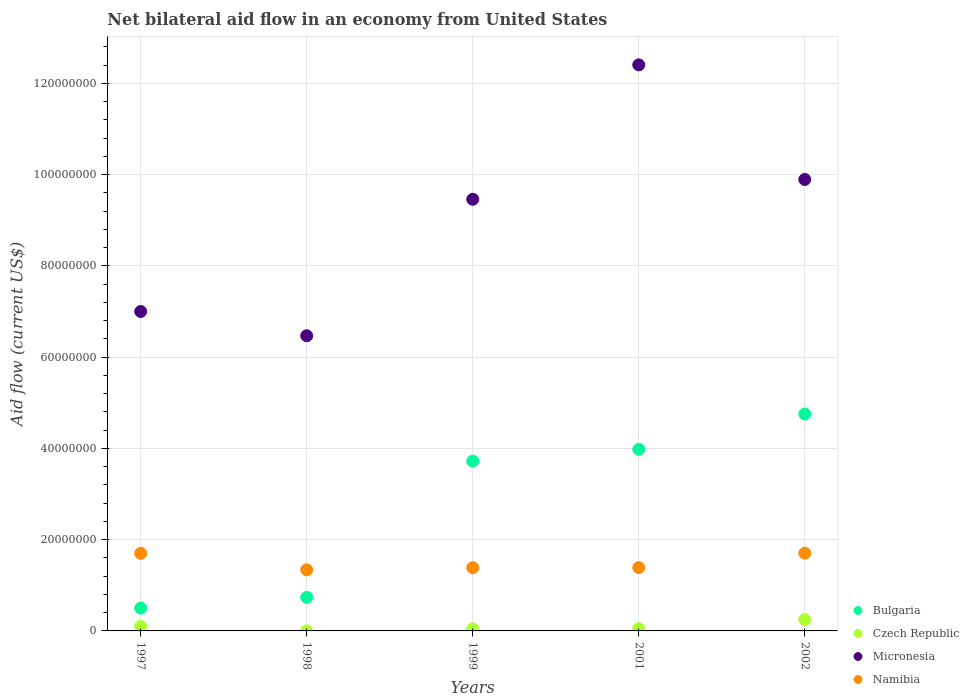Is the number of dotlines equal to the number of legend labels?
Your answer should be compact. Yes. What is the net bilateral aid flow in Namibia in 2002?
Offer a terse response. 1.70e+07. Across all years, what is the maximum net bilateral aid flow in Czech Republic?
Your response must be concise. 2.49e+06. Across all years, what is the minimum net bilateral aid flow in Bulgaria?
Offer a very short reply. 5.00e+06. In which year was the net bilateral aid flow in Micronesia maximum?
Ensure brevity in your answer.  2001. In which year was the net bilateral aid flow in Bulgaria minimum?
Provide a short and direct response. 1997. What is the total net bilateral aid flow in Czech Republic in the graph?
Provide a succinct answer. 4.45e+06. What is the difference between the net bilateral aid flow in Micronesia in 1998 and that in 2002?
Ensure brevity in your answer.  -3.42e+07. What is the difference between the net bilateral aid flow in Micronesia in 1997 and the net bilateral aid flow in Namibia in 2001?
Your answer should be compact. 5.61e+07. What is the average net bilateral aid flow in Namibia per year?
Keep it short and to the point. 1.50e+07. In the year 1997, what is the difference between the net bilateral aid flow in Bulgaria and net bilateral aid flow in Namibia?
Ensure brevity in your answer.  -1.20e+07. In how many years, is the net bilateral aid flow in Czech Republic greater than 56000000 US$?
Ensure brevity in your answer.  0. What is the ratio of the net bilateral aid flow in Namibia in 1997 to that in 1999?
Give a very brief answer. 1.23. What is the difference between the highest and the second highest net bilateral aid flow in Namibia?
Make the answer very short. 3.00e+04. What is the difference between the highest and the lowest net bilateral aid flow in Micronesia?
Offer a very short reply. 5.94e+07. In how many years, is the net bilateral aid flow in Micronesia greater than the average net bilateral aid flow in Micronesia taken over all years?
Give a very brief answer. 3. Is it the case that in every year, the sum of the net bilateral aid flow in Namibia and net bilateral aid flow in Micronesia  is greater than the sum of net bilateral aid flow in Bulgaria and net bilateral aid flow in Czech Republic?
Your answer should be very brief. Yes. Is it the case that in every year, the sum of the net bilateral aid flow in Micronesia and net bilateral aid flow in Czech Republic  is greater than the net bilateral aid flow in Namibia?
Provide a succinct answer. Yes. Is the net bilateral aid flow in Bulgaria strictly greater than the net bilateral aid flow in Czech Republic over the years?
Make the answer very short. Yes. How many dotlines are there?
Provide a short and direct response. 4. How many years are there in the graph?
Ensure brevity in your answer.  5. Are the values on the major ticks of Y-axis written in scientific E-notation?
Provide a short and direct response. No. Does the graph contain any zero values?
Provide a short and direct response. No. Does the graph contain grids?
Provide a succinct answer. Yes. How are the legend labels stacked?
Offer a terse response. Vertical. What is the title of the graph?
Your answer should be very brief. Net bilateral aid flow in an economy from United States. What is the label or title of the Y-axis?
Your response must be concise. Aid flow (current US$). What is the Aid flow (current US$) in Czech Republic in 1997?
Give a very brief answer. 1.00e+06. What is the Aid flow (current US$) of Micronesia in 1997?
Provide a short and direct response. 7.00e+07. What is the Aid flow (current US$) in Namibia in 1997?
Your answer should be compact. 1.70e+07. What is the Aid flow (current US$) in Bulgaria in 1998?
Provide a succinct answer. 7.36e+06. What is the Aid flow (current US$) of Micronesia in 1998?
Your answer should be very brief. 6.47e+07. What is the Aid flow (current US$) in Namibia in 1998?
Provide a short and direct response. 1.34e+07. What is the Aid flow (current US$) in Bulgaria in 1999?
Your answer should be very brief. 3.72e+07. What is the Aid flow (current US$) of Micronesia in 1999?
Ensure brevity in your answer.  9.46e+07. What is the Aid flow (current US$) of Namibia in 1999?
Provide a short and direct response. 1.39e+07. What is the Aid flow (current US$) in Bulgaria in 2001?
Give a very brief answer. 3.98e+07. What is the Aid flow (current US$) of Czech Republic in 2001?
Provide a short and direct response. 5.00e+05. What is the Aid flow (current US$) of Micronesia in 2001?
Give a very brief answer. 1.24e+08. What is the Aid flow (current US$) in Namibia in 2001?
Keep it short and to the point. 1.39e+07. What is the Aid flow (current US$) in Bulgaria in 2002?
Offer a terse response. 4.75e+07. What is the Aid flow (current US$) of Czech Republic in 2002?
Make the answer very short. 2.49e+06. What is the Aid flow (current US$) in Micronesia in 2002?
Provide a succinct answer. 9.89e+07. What is the Aid flow (current US$) of Namibia in 2002?
Offer a very short reply. 1.70e+07. Across all years, what is the maximum Aid flow (current US$) in Bulgaria?
Offer a terse response. 4.75e+07. Across all years, what is the maximum Aid flow (current US$) in Czech Republic?
Your answer should be compact. 2.49e+06. Across all years, what is the maximum Aid flow (current US$) of Micronesia?
Offer a terse response. 1.24e+08. Across all years, what is the maximum Aid flow (current US$) in Namibia?
Offer a very short reply. 1.70e+07. Across all years, what is the minimum Aid flow (current US$) in Bulgaria?
Your answer should be very brief. 5.00e+06. Across all years, what is the minimum Aid flow (current US$) of Micronesia?
Your answer should be very brief. 6.47e+07. Across all years, what is the minimum Aid flow (current US$) in Namibia?
Your response must be concise. 1.34e+07. What is the total Aid flow (current US$) of Bulgaria in the graph?
Ensure brevity in your answer.  1.37e+08. What is the total Aid flow (current US$) of Czech Republic in the graph?
Keep it short and to the point. 4.45e+06. What is the total Aid flow (current US$) of Micronesia in the graph?
Provide a succinct answer. 4.52e+08. What is the total Aid flow (current US$) of Namibia in the graph?
Offer a terse response. 7.52e+07. What is the difference between the Aid flow (current US$) of Bulgaria in 1997 and that in 1998?
Provide a short and direct response. -2.36e+06. What is the difference between the Aid flow (current US$) of Czech Republic in 1997 and that in 1998?
Provide a short and direct response. 9.90e+05. What is the difference between the Aid flow (current US$) of Micronesia in 1997 and that in 1998?
Offer a very short reply. 5.32e+06. What is the difference between the Aid flow (current US$) of Namibia in 1997 and that in 1998?
Your answer should be very brief. 3.61e+06. What is the difference between the Aid flow (current US$) in Bulgaria in 1997 and that in 1999?
Keep it short and to the point. -3.22e+07. What is the difference between the Aid flow (current US$) in Czech Republic in 1997 and that in 1999?
Your answer should be very brief. 5.50e+05. What is the difference between the Aid flow (current US$) of Micronesia in 1997 and that in 1999?
Provide a short and direct response. -2.46e+07. What is the difference between the Aid flow (current US$) in Namibia in 1997 and that in 1999?
Ensure brevity in your answer.  3.14e+06. What is the difference between the Aid flow (current US$) in Bulgaria in 1997 and that in 2001?
Your answer should be very brief. -3.48e+07. What is the difference between the Aid flow (current US$) in Micronesia in 1997 and that in 2001?
Provide a succinct answer. -5.40e+07. What is the difference between the Aid flow (current US$) in Namibia in 1997 and that in 2001?
Your answer should be compact. 3.12e+06. What is the difference between the Aid flow (current US$) in Bulgaria in 1997 and that in 2002?
Offer a very short reply. -4.25e+07. What is the difference between the Aid flow (current US$) of Czech Republic in 1997 and that in 2002?
Offer a very short reply. -1.49e+06. What is the difference between the Aid flow (current US$) of Micronesia in 1997 and that in 2002?
Offer a terse response. -2.89e+07. What is the difference between the Aid flow (current US$) in Bulgaria in 1998 and that in 1999?
Your answer should be very brief. -2.98e+07. What is the difference between the Aid flow (current US$) of Czech Republic in 1998 and that in 1999?
Your response must be concise. -4.40e+05. What is the difference between the Aid flow (current US$) in Micronesia in 1998 and that in 1999?
Offer a very short reply. -2.99e+07. What is the difference between the Aid flow (current US$) of Namibia in 1998 and that in 1999?
Your answer should be very brief. -4.70e+05. What is the difference between the Aid flow (current US$) in Bulgaria in 1998 and that in 2001?
Your response must be concise. -3.24e+07. What is the difference between the Aid flow (current US$) in Czech Republic in 1998 and that in 2001?
Keep it short and to the point. -4.90e+05. What is the difference between the Aid flow (current US$) in Micronesia in 1998 and that in 2001?
Your answer should be very brief. -5.94e+07. What is the difference between the Aid flow (current US$) of Namibia in 1998 and that in 2001?
Make the answer very short. -4.90e+05. What is the difference between the Aid flow (current US$) of Bulgaria in 1998 and that in 2002?
Ensure brevity in your answer.  -4.02e+07. What is the difference between the Aid flow (current US$) in Czech Republic in 1998 and that in 2002?
Your answer should be very brief. -2.48e+06. What is the difference between the Aid flow (current US$) of Micronesia in 1998 and that in 2002?
Your response must be concise. -3.42e+07. What is the difference between the Aid flow (current US$) of Namibia in 1998 and that in 2002?
Offer a terse response. -3.64e+06. What is the difference between the Aid flow (current US$) of Bulgaria in 1999 and that in 2001?
Your answer should be compact. -2.58e+06. What is the difference between the Aid flow (current US$) of Micronesia in 1999 and that in 2001?
Give a very brief answer. -2.94e+07. What is the difference between the Aid flow (current US$) of Bulgaria in 1999 and that in 2002?
Keep it short and to the point. -1.03e+07. What is the difference between the Aid flow (current US$) of Czech Republic in 1999 and that in 2002?
Provide a succinct answer. -2.04e+06. What is the difference between the Aid flow (current US$) in Micronesia in 1999 and that in 2002?
Give a very brief answer. -4.34e+06. What is the difference between the Aid flow (current US$) in Namibia in 1999 and that in 2002?
Ensure brevity in your answer.  -3.17e+06. What is the difference between the Aid flow (current US$) in Bulgaria in 2001 and that in 2002?
Offer a very short reply. -7.74e+06. What is the difference between the Aid flow (current US$) of Czech Republic in 2001 and that in 2002?
Your response must be concise. -1.99e+06. What is the difference between the Aid flow (current US$) in Micronesia in 2001 and that in 2002?
Offer a terse response. 2.51e+07. What is the difference between the Aid flow (current US$) in Namibia in 2001 and that in 2002?
Provide a short and direct response. -3.15e+06. What is the difference between the Aid flow (current US$) of Bulgaria in 1997 and the Aid flow (current US$) of Czech Republic in 1998?
Keep it short and to the point. 4.99e+06. What is the difference between the Aid flow (current US$) of Bulgaria in 1997 and the Aid flow (current US$) of Micronesia in 1998?
Offer a very short reply. -5.97e+07. What is the difference between the Aid flow (current US$) of Bulgaria in 1997 and the Aid flow (current US$) of Namibia in 1998?
Ensure brevity in your answer.  -8.39e+06. What is the difference between the Aid flow (current US$) in Czech Republic in 1997 and the Aid flow (current US$) in Micronesia in 1998?
Provide a succinct answer. -6.37e+07. What is the difference between the Aid flow (current US$) of Czech Republic in 1997 and the Aid flow (current US$) of Namibia in 1998?
Give a very brief answer. -1.24e+07. What is the difference between the Aid flow (current US$) in Micronesia in 1997 and the Aid flow (current US$) in Namibia in 1998?
Your answer should be very brief. 5.66e+07. What is the difference between the Aid flow (current US$) in Bulgaria in 1997 and the Aid flow (current US$) in Czech Republic in 1999?
Your answer should be compact. 4.55e+06. What is the difference between the Aid flow (current US$) of Bulgaria in 1997 and the Aid flow (current US$) of Micronesia in 1999?
Provide a succinct answer. -8.96e+07. What is the difference between the Aid flow (current US$) in Bulgaria in 1997 and the Aid flow (current US$) in Namibia in 1999?
Provide a succinct answer. -8.86e+06. What is the difference between the Aid flow (current US$) in Czech Republic in 1997 and the Aid flow (current US$) in Micronesia in 1999?
Your answer should be compact. -9.36e+07. What is the difference between the Aid flow (current US$) of Czech Republic in 1997 and the Aid flow (current US$) of Namibia in 1999?
Your answer should be compact. -1.29e+07. What is the difference between the Aid flow (current US$) in Micronesia in 1997 and the Aid flow (current US$) in Namibia in 1999?
Your response must be concise. 5.61e+07. What is the difference between the Aid flow (current US$) of Bulgaria in 1997 and the Aid flow (current US$) of Czech Republic in 2001?
Ensure brevity in your answer.  4.50e+06. What is the difference between the Aid flow (current US$) in Bulgaria in 1997 and the Aid flow (current US$) in Micronesia in 2001?
Your response must be concise. -1.19e+08. What is the difference between the Aid flow (current US$) in Bulgaria in 1997 and the Aid flow (current US$) in Namibia in 2001?
Your answer should be compact. -8.88e+06. What is the difference between the Aid flow (current US$) of Czech Republic in 1997 and the Aid flow (current US$) of Micronesia in 2001?
Make the answer very short. -1.23e+08. What is the difference between the Aid flow (current US$) of Czech Republic in 1997 and the Aid flow (current US$) of Namibia in 2001?
Provide a succinct answer. -1.29e+07. What is the difference between the Aid flow (current US$) in Micronesia in 1997 and the Aid flow (current US$) in Namibia in 2001?
Your answer should be very brief. 5.61e+07. What is the difference between the Aid flow (current US$) in Bulgaria in 1997 and the Aid flow (current US$) in Czech Republic in 2002?
Provide a succinct answer. 2.51e+06. What is the difference between the Aid flow (current US$) in Bulgaria in 1997 and the Aid flow (current US$) in Micronesia in 2002?
Make the answer very short. -9.39e+07. What is the difference between the Aid flow (current US$) in Bulgaria in 1997 and the Aid flow (current US$) in Namibia in 2002?
Keep it short and to the point. -1.20e+07. What is the difference between the Aid flow (current US$) in Czech Republic in 1997 and the Aid flow (current US$) in Micronesia in 2002?
Keep it short and to the point. -9.79e+07. What is the difference between the Aid flow (current US$) in Czech Republic in 1997 and the Aid flow (current US$) in Namibia in 2002?
Keep it short and to the point. -1.60e+07. What is the difference between the Aid flow (current US$) of Micronesia in 1997 and the Aid flow (current US$) of Namibia in 2002?
Provide a short and direct response. 5.30e+07. What is the difference between the Aid flow (current US$) in Bulgaria in 1998 and the Aid flow (current US$) in Czech Republic in 1999?
Provide a succinct answer. 6.91e+06. What is the difference between the Aid flow (current US$) in Bulgaria in 1998 and the Aid flow (current US$) in Micronesia in 1999?
Ensure brevity in your answer.  -8.72e+07. What is the difference between the Aid flow (current US$) of Bulgaria in 1998 and the Aid flow (current US$) of Namibia in 1999?
Your answer should be very brief. -6.50e+06. What is the difference between the Aid flow (current US$) of Czech Republic in 1998 and the Aid flow (current US$) of Micronesia in 1999?
Provide a short and direct response. -9.46e+07. What is the difference between the Aid flow (current US$) in Czech Republic in 1998 and the Aid flow (current US$) in Namibia in 1999?
Your answer should be very brief. -1.38e+07. What is the difference between the Aid flow (current US$) of Micronesia in 1998 and the Aid flow (current US$) of Namibia in 1999?
Keep it short and to the point. 5.08e+07. What is the difference between the Aid flow (current US$) in Bulgaria in 1998 and the Aid flow (current US$) in Czech Republic in 2001?
Your answer should be very brief. 6.86e+06. What is the difference between the Aid flow (current US$) in Bulgaria in 1998 and the Aid flow (current US$) in Micronesia in 2001?
Provide a short and direct response. -1.17e+08. What is the difference between the Aid flow (current US$) in Bulgaria in 1998 and the Aid flow (current US$) in Namibia in 2001?
Your answer should be very brief. -6.52e+06. What is the difference between the Aid flow (current US$) of Czech Republic in 1998 and the Aid flow (current US$) of Micronesia in 2001?
Provide a succinct answer. -1.24e+08. What is the difference between the Aid flow (current US$) in Czech Republic in 1998 and the Aid flow (current US$) in Namibia in 2001?
Give a very brief answer. -1.39e+07. What is the difference between the Aid flow (current US$) of Micronesia in 1998 and the Aid flow (current US$) of Namibia in 2001?
Make the answer very short. 5.08e+07. What is the difference between the Aid flow (current US$) of Bulgaria in 1998 and the Aid flow (current US$) of Czech Republic in 2002?
Your answer should be very brief. 4.87e+06. What is the difference between the Aid flow (current US$) of Bulgaria in 1998 and the Aid flow (current US$) of Micronesia in 2002?
Provide a succinct answer. -9.16e+07. What is the difference between the Aid flow (current US$) of Bulgaria in 1998 and the Aid flow (current US$) of Namibia in 2002?
Offer a very short reply. -9.67e+06. What is the difference between the Aid flow (current US$) of Czech Republic in 1998 and the Aid flow (current US$) of Micronesia in 2002?
Provide a short and direct response. -9.89e+07. What is the difference between the Aid flow (current US$) of Czech Republic in 1998 and the Aid flow (current US$) of Namibia in 2002?
Provide a succinct answer. -1.70e+07. What is the difference between the Aid flow (current US$) of Micronesia in 1998 and the Aid flow (current US$) of Namibia in 2002?
Offer a very short reply. 4.76e+07. What is the difference between the Aid flow (current US$) in Bulgaria in 1999 and the Aid flow (current US$) in Czech Republic in 2001?
Offer a terse response. 3.67e+07. What is the difference between the Aid flow (current US$) in Bulgaria in 1999 and the Aid flow (current US$) in Micronesia in 2001?
Your answer should be very brief. -8.68e+07. What is the difference between the Aid flow (current US$) of Bulgaria in 1999 and the Aid flow (current US$) of Namibia in 2001?
Ensure brevity in your answer.  2.33e+07. What is the difference between the Aid flow (current US$) in Czech Republic in 1999 and the Aid flow (current US$) in Micronesia in 2001?
Your answer should be compact. -1.24e+08. What is the difference between the Aid flow (current US$) of Czech Republic in 1999 and the Aid flow (current US$) of Namibia in 2001?
Provide a succinct answer. -1.34e+07. What is the difference between the Aid flow (current US$) of Micronesia in 1999 and the Aid flow (current US$) of Namibia in 2001?
Provide a succinct answer. 8.07e+07. What is the difference between the Aid flow (current US$) of Bulgaria in 1999 and the Aid flow (current US$) of Czech Republic in 2002?
Ensure brevity in your answer.  3.47e+07. What is the difference between the Aid flow (current US$) in Bulgaria in 1999 and the Aid flow (current US$) in Micronesia in 2002?
Give a very brief answer. -6.17e+07. What is the difference between the Aid flow (current US$) of Bulgaria in 1999 and the Aid flow (current US$) of Namibia in 2002?
Give a very brief answer. 2.02e+07. What is the difference between the Aid flow (current US$) in Czech Republic in 1999 and the Aid flow (current US$) in Micronesia in 2002?
Offer a terse response. -9.85e+07. What is the difference between the Aid flow (current US$) in Czech Republic in 1999 and the Aid flow (current US$) in Namibia in 2002?
Offer a very short reply. -1.66e+07. What is the difference between the Aid flow (current US$) in Micronesia in 1999 and the Aid flow (current US$) in Namibia in 2002?
Offer a terse response. 7.76e+07. What is the difference between the Aid flow (current US$) in Bulgaria in 2001 and the Aid flow (current US$) in Czech Republic in 2002?
Offer a terse response. 3.73e+07. What is the difference between the Aid flow (current US$) of Bulgaria in 2001 and the Aid flow (current US$) of Micronesia in 2002?
Your answer should be very brief. -5.91e+07. What is the difference between the Aid flow (current US$) in Bulgaria in 2001 and the Aid flow (current US$) in Namibia in 2002?
Provide a short and direct response. 2.28e+07. What is the difference between the Aid flow (current US$) of Czech Republic in 2001 and the Aid flow (current US$) of Micronesia in 2002?
Offer a terse response. -9.84e+07. What is the difference between the Aid flow (current US$) of Czech Republic in 2001 and the Aid flow (current US$) of Namibia in 2002?
Your answer should be very brief. -1.65e+07. What is the difference between the Aid flow (current US$) in Micronesia in 2001 and the Aid flow (current US$) in Namibia in 2002?
Provide a short and direct response. 1.07e+08. What is the average Aid flow (current US$) of Bulgaria per year?
Offer a terse response. 2.74e+07. What is the average Aid flow (current US$) of Czech Republic per year?
Offer a terse response. 8.90e+05. What is the average Aid flow (current US$) in Micronesia per year?
Your answer should be very brief. 9.04e+07. What is the average Aid flow (current US$) in Namibia per year?
Provide a succinct answer. 1.50e+07. In the year 1997, what is the difference between the Aid flow (current US$) of Bulgaria and Aid flow (current US$) of Czech Republic?
Your answer should be compact. 4.00e+06. In the year 1997, what is the difference between the Aid flow (current US$) of Bulgaria and Aid flow (current US$) of Micronesia?
Your response must be concise. -6.50e+07. In the year 1997, what is the difference between the Aid flow (current US$) of Bulgaria and Aid flow (current US$) of Namibia?
Make the answer very short. -1.20e+07. In the year 1997, what is the difference between the Aid flow (current US$) in Czech Republic and Aid flow (current US$) in Micronesia?
Provide a short and direct response. -6.90e+07. In the year 1997, what is the difference between the Aid flow (current US$) in Czech Republic and Aid flow (current US$) in Namibia?
Provide a short and direct response. -1.60e+07. In the year 1997, what is the difference between the Aid flow (current US$) of Micronesia and Aid flow (current US$) of Namibia?
Offer a very short reply. 5.30e+07. In the year 1998, what is the difference between the Aid flow (current US$) of Bulgaria and Aid flow (current US$) of Czech Republic?
Your answer should be compact. 7.35e+06. In the year 1998, what is the difference between the Aid flow (current US$) in Bulgaria and Aid flow (current US$) in Micronesia?
Provide a short and direct response. -5.73e+07. In the year 1998, what is the difference between the Aid flow (current US$) in Bulgaria and Aid flow (current US$) in Namibia?
Offer a very short reply. -6.03e+06. In the year 1998, what is the difference between the Aid flow (current US$) in Czech Republic and Aid flow (current US$) in Micronesia?
Ensure brevity in your answer.  -6.47e+07. In the year 1998, what is the difference between the Aid flow (current US$) of Czech Republic and Aid flow (current US$) of Namibia?
Your answer should be compact. -1.34e+07. In the year 1998, what is the difference between the Aid flow (current US$) of Micronesia and Aid flow (current US$) of Namibia?
Your answer should be very brief. 5.13e+07. In the year 1999, what is the difference between the Aid flow (current US$) in Bulgaria and Aid flow (current US$) in Czech Republic?
Make the answer very short. 3.68e+07. In the year 1999, what is the difference between the Aid flow (current US$) in Bulgaria and Aid flow (current US$) in Micronesia?
Provide a short and direct response. -5.74e+07. In the year 1999, what is the difference between the Aid flow (current US$) in Bulgaria and Aid flow (current US$) in Namibia?
Provide a short and direct response. 2.34e+07. In the year 1999, what is the difference between the Aid flow (current US$) in Czech Republic and Aid flow (current US$) in Micronesia?
Offer a terse response. -9.41e+07. In the year 1999, what is the difference between the Aid flow (current US$) of Czech Republic and Aid flow (current US$) of Namibia?
Ensure brevity in your answer.  -1.34e+07. In the year 1999, what is the difference between the Aid flow (current US$) of Micronesia and Aid flow (current US$) of Namibia?
Make the answer very short. 8.07e+07. In the year 2001, what is the difference between the Aid flow (current US$) in Bulgaria and Aid flow (current US$) in Czech Republic?
Ensure brevity in your answer.  3.93e+07. In the year 2001, what is the difference between the Aid flow (current US$) of Bulgaria and Aid flow (current US$) of Micronesia?
Ensure brevity in your answer.  -8.42e+07. In the year 2001, what is the difference between the Aid flow (current US$) of Bulgaria and Aid flow (current US$) of Namibia?
Your answer should be compact. 2.59e+07. In the year 2001, what is the difference between the Aid flow (current US$) in Czech Republic and Aid flow (current US$) in Micronesia?
Offer a terse response. -1.24e+08. In the year 2001, what is the difference between the Aid flow (current US$) in Czech Republic and Aid flow (current US$) in Namibia?
Keep it short and to the point. -1.34e+07. In the year 2001, what is the difference between the Aid flow (current US$) of Micronesia and Aid flow (current US$) of Namibia?
Give a very brief answer. 1.10e+08. In the year 2002, what is the difference between the Aid flow (current US$) of Bulgaria and Aid flow (current US$) of Czech Republic?
Offer a very short reply. 4.50e+07. In the year 2002, what is the difference between the Aid flow (current US$) of Bulgaria and Aid flow (current US$) of Micronesia?
Your response must be concise. -5.14e+07. In the year 2002, what is the difference between the Aid flow (current US$) of Bulgaria and Aid flow (current US$) of Namibia?
Offer a very short reply. 3.05e+07. In the year 2002, what is the difference between the Aid flow (current US$) in Czech Republic and Aid flow (current US$) in Micronesia?
Your answer should be very brief. -9.64e+07. In the year 2002, what is the difference between the Aid flow (current US$) of Czech Republic and Aid flow (current US$) of Namibia?
Your response must be concise. -1.45e+07. In the year 2002, what is the difference between the Aid flow (current US$) in Micronesia and Aid flow (current US$) in Namibia?
Provide a succinct answer. 8.19e+07. What is the ratio of the Aid flow (current US$) in Bulgaria in 1997 to that in 1998?
Your answer should be very brief. 0.68. What is the ratio of the Aid flow (current US$) in Czech Republic in 1997 to that in 1998?
Provide a succinct answer. 100. What is the ratio of the Aid flow (current US$) of Micronesia in 1997 to that in 1998?
Offer a very short reply. 1.08. What is the ratio of the Aid flow (current US$) of Namibia in 1997 to that in 1998?
Your answer should be compact. 1.27. What is the ratio of the Aid flow (current US$) in Bulgaria in 1997 to that in 1999?
Offer a terse response. 0.13. What is the ratio of the Aid flow (current US$) of Czech Republic in 1997 to that in 1999?
Your answer should be compact. 2.22. What is the ratio of the Aid flow (current US$) of Micronesia in 1997 to that in 1999?
Make the answer very short. 0.74. What is the ratio of the Aid flow (current US$) of Namibia in 1997 to that in 1999?
Provide a short and direct response. 1.23. What is the ratio of the Aid flow (current US$) in Bulgaria in 1997 to that in 2001?
Ensure brevity in your answer.  0.13. What is the ratio of the Aid flow (current US$) of Micronesia in 1997 to that in 2001?
Offer a very short reply. 0.56. What is the ratio of the Aid flow (current US$) of Namibia in 1997 to that in 2001?
Your answer should be very brief. 1.22. What is the ratio of the Aid flow (current US$) in Bulgaria in 1997 to that in 2002?
Make the answer very short. 0.11. What is the ratio of the Aid flow (current US$) of Czech Republic in 1997 to that in 2002?
Offer a very short reply. 0.4. What is the ratio of the Aid flow (current US$) of Micronesia in 1997 to that in 2002?
Your answer should be compact. 0.71. What is the ratio of the Aid flow (current US$) of Namibia in 1997 to that in 2002?
Your response must be concise. 1. What is the ratio of the Aid flow (current US$) of Bulgaria in 1998 to that in 1999?
Your response must be concise. 0.2. What is the ratio of the Aid flow (current US$) in Czech Republic in 1998 to that in 1999?
Provide a succinct answer. 0.02. What is the ratio of the Aid flow (current US$) in Micronesia in 1998 to that in 1999?
Your answer should be compact. 0.68. What is the ratio of the Aid flow (current US$) of Namibia in 1998 to that in 1999?
Your answer should be compact. 0.97. What is the ratio of the Aid flow (current US$) in Bulgaria in 1998 to that in 2001?
Your answer should be very brief. 0.18. What is the ratio of the Aid flow (current US$) of Micronesia in 1998 to that in 2001?
Your answer should be very brief. 0.52. What is the ratio of the Aid flow (current US$) of Namibia in 1998 to that in 2001?
Provide a short and direct response. 0.96. What is the ratio of the Aid flow (current US$) of Bulgaria in 1998 to that in 2002?
Ensure brevity in your answer.  0.15. What is the ratio of the Aid flow (current US$) of Czech Republic in 1998 to that in 2002?
Keep it short and to the point. 0. What is the ratio of the Aid flow (current US$) in Micronesia in 1998 to that in 2002?
Your response must be concise. 0.65. What is the ratio of the Aid flow (current US$) in Namibia in 1998 to that in 2002?
Offer a terse response. 0.79. What is the ratio of the Aid flow (current US$) in Bulgaria in 1999 to that in 2001?
Give a very brief answer. 0.94. What is the ratio of the Aid flow (current US$) of Micronesia in 1999 to that in 2001?
Keep it short and to the point. 0.76. What is the ratio of the Aid flow (current US$) in Bulgaria in 1999 to that in 2002?
Keep it short and to the point. 0.78. What is the ratio of the Aid flow (current US$) in Czech Republic in 1999 to that in 2002?
Offer a terse response. 0.18. What is the ratio of the Aid flow (current US$) of Micronesia in 1999 to that in 2002?
Your answer should be very brief. 0.96. What is the ratio of the Aid flow (current US$) of Namibia in 1999 to that in 2002?
Provide a short and direct response. 0.81. What is the ratio of the Aid flow (current US$) in Bulgaria in 2001 to that in 2002?
Provide a short and direct response. 0.84. What is the ratio of the Aid flow (current US$) in Czech Republic in 2001 to that in 2002?
Your answer should be very brief. 0.2. What is the ratio of the Aid flow (current US$) of Micronesia in 2001 to that in 2002?
Offer a very short reply. 1.25. What is the ratio of the Aid flow (current US$) of Namibia in 2001 to that in 2002?
Provide a succinct answer. 0.81. What is the difference between the highest and the second highest Aid flow (current US$) of Bulgaria?
Your response must be concise. 7.74e+06. What is the difference between the highest and the second highest Aid flow (current US$) in Czech Republic?
Your answer should be very brief. 1.49e+06. What is the difference between the highest and the second highest Aid flow (current US$) of Micronesia?
Give a very brief answer. 2.51e+07. What is the difference between the highest and the second highest Aid flow (current US$) of Namibia?
Ensure brevity in your answer.  3.00e+04. What is the difference between the highest and the lowest Aid flow (current US$) in Bulgaria?
Provide a short and direct response. 4.25e+07. What is the difference between the highest and the lowest Aid flow (current US$) of Czech Republic?
Give a very brief answer. 2.48e+06. What is the difference between the highest and the lowest Aid flow (current US$) in Micronesia?
Your answer should be very brief. 5.94e+07. What is the difference between the highest and the lowest Aid flow (current US$) of Namibia?
Keep it short and to the point. 3.64e+06. 